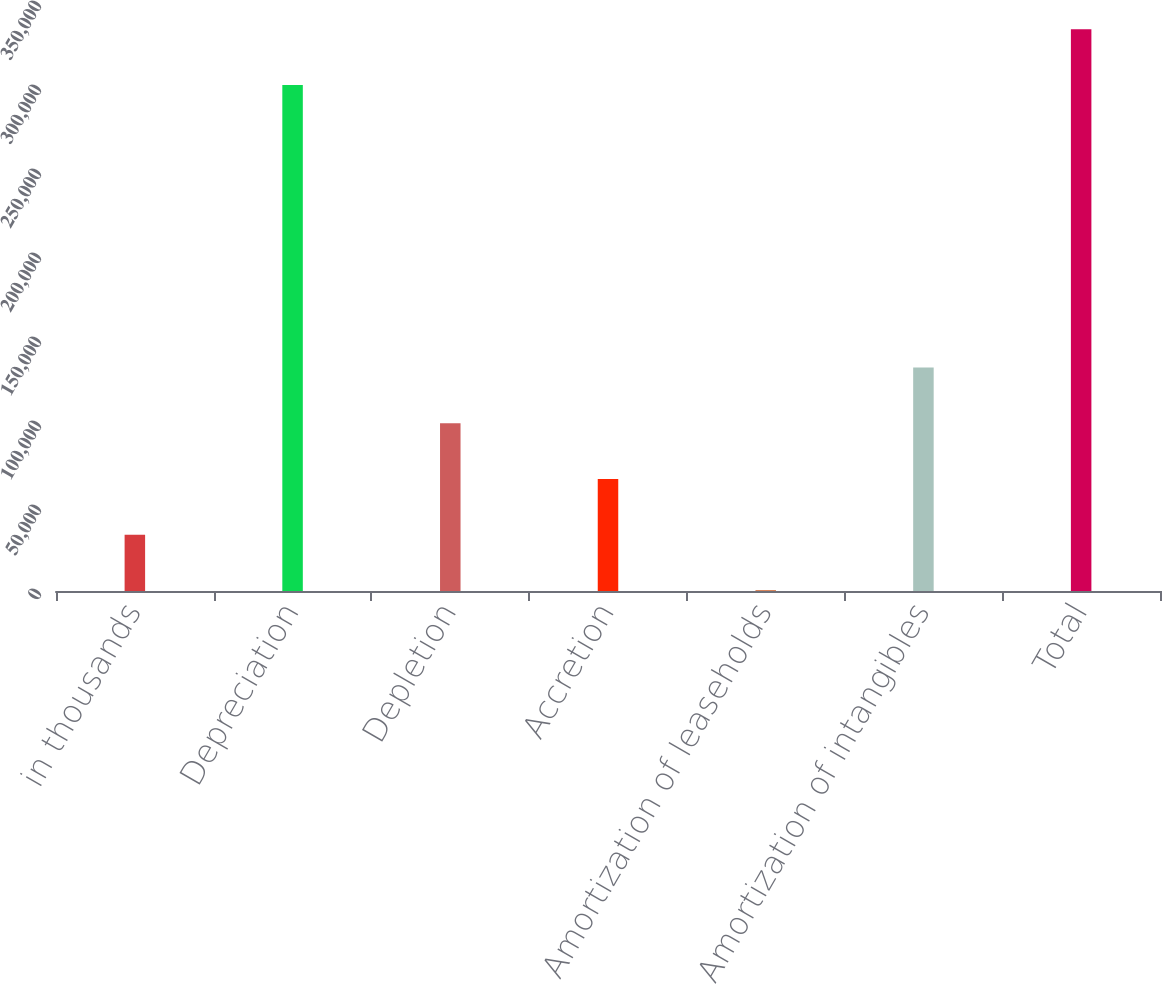<chart> <loc_0><loc_0><loc_500><loc_500><bar_chart><fcel>in thousands<fcel>Depreciation<fcel>Depletion<fcel>Accretion<fcel>Amortization of leaseholds<fcel>Amortization of intangibles<fcel>Total<nl><fcel>33538.8<fcel>301146<fcel>99854.4<fcel>66696.6<fcel>381<fcel>133012<fcel>334304<nl></chart> 